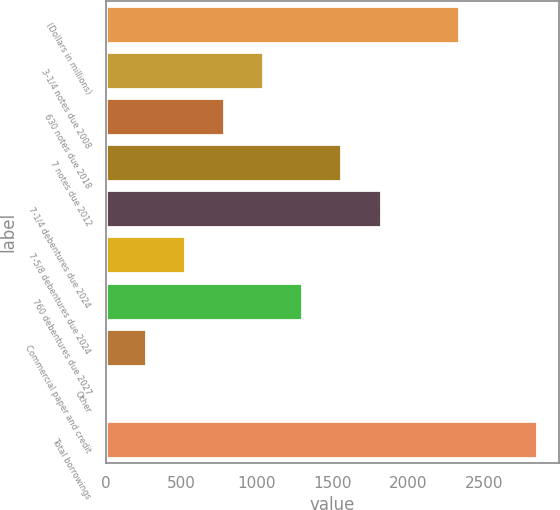<chart> <loc_0><loc_0><loc_500><loc_500><bar_chart><fcel>(Dollars in millions)<fcel>3-1/4 notes due 2008<fcel>630 notes due 2018<fcel>7 notes due 2012<fcel>7-1/4 debentures due 2024<fcel>7-5/8 debentures due 2024<fcel>760 debentures due 2027<fcel>Commercial paper and credit<fcel>Other<fcel>Total borrowings<nl><fcel>2334.4<fcel>1041.4<fcel>782.8<fcel>1558.6<fcel>1817.2<fcel>524.2<fcel>1300<fcel>265.6<fcel>7<fcel>2851.6<nl></chart> 